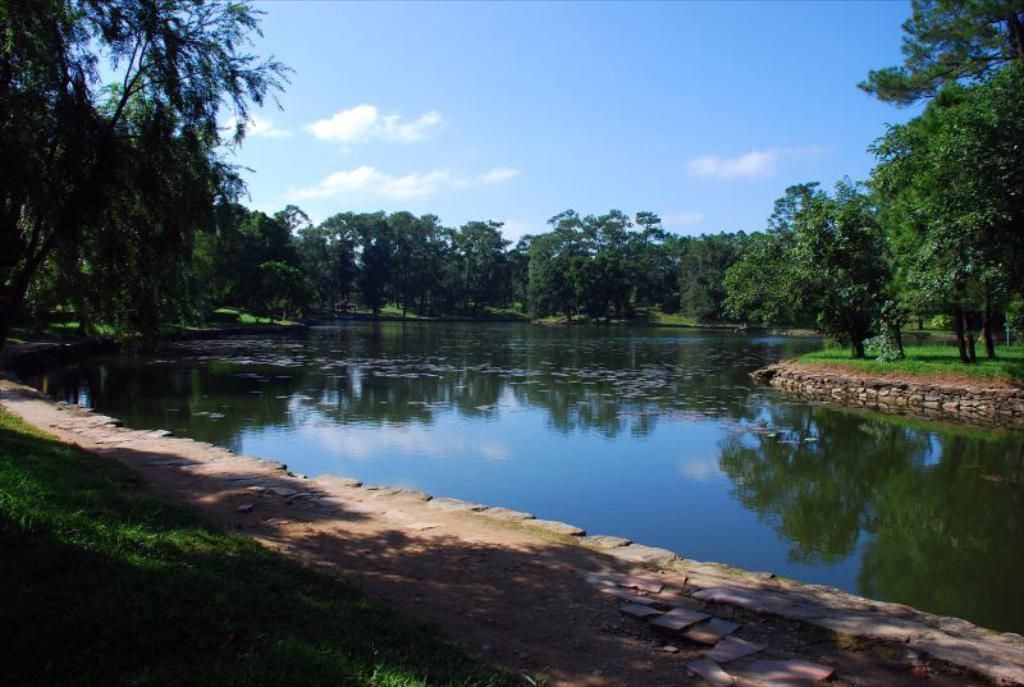What type of vegetation is present on the ground in the front of the image? There is grass on the ground in the front of the image. What is located in the center of the image? There is water in the center of the image. What can be seen in the background of the image? There are trees and grass in the background of the image. What is the condition of the sky in the background of the image? The sky is cloudy in the background of the image. How many toes are visible in the image? There are no toes visible in the image. What type of knowledge is being shared in the image? There is no indication of any knowledge being shared in the image. 